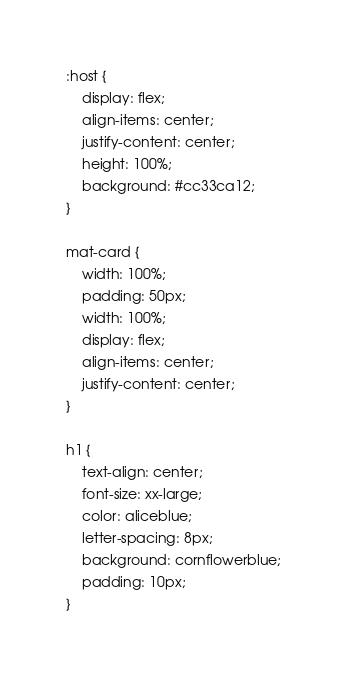<code> <loc_0><loc_0><loc_500><loc_500><_CSS_>:host {
    display: flex;
    align-items: center;
    justify-content: center;
    height: 100%;
    background: #cc33ca12;
}

mat-card {
    width: 100%;
    padding: 50px;
    width: 100%;
    display: flex;
    align-items: center;
    justify-content: center;
}

h1 {
    text-align: center;
    font-size: xx-large;
    color: aliceblue;
    letter-spacing: 8px;
    background: cornflowerblue;
    padding: 10px;
}</code> 